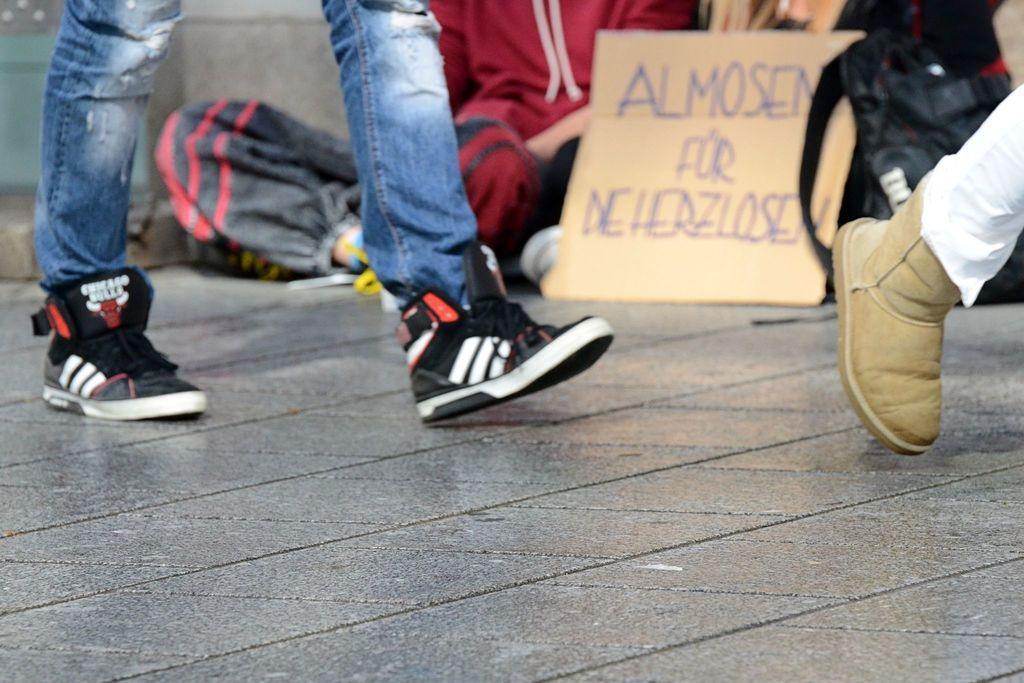Could you give a brief overview of what you see in this image? In the center of the image we can see the person's legs are there. At the top of the image a person is sitting and also we can see boar, bag, wall are there. At the bottom of the image floor is there. 